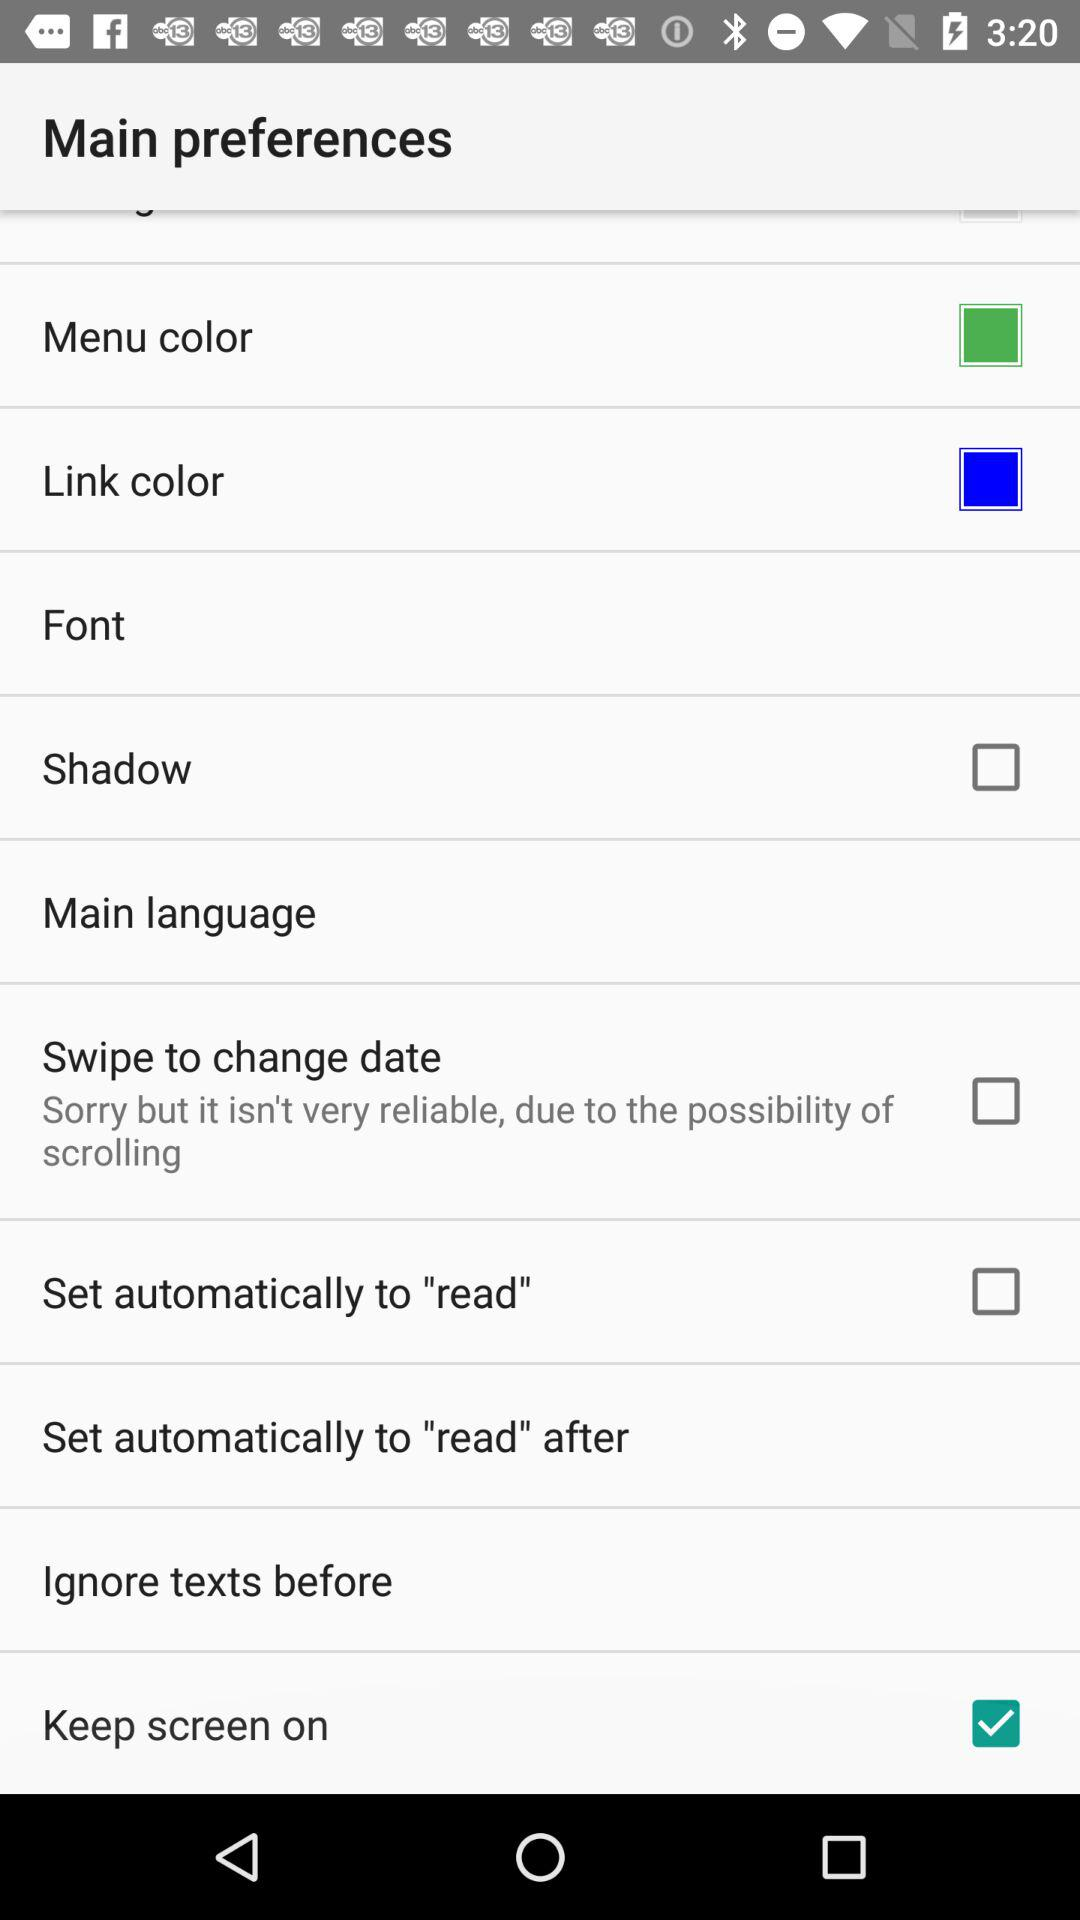What is the status of "Keep screen on"? The status is "on". 